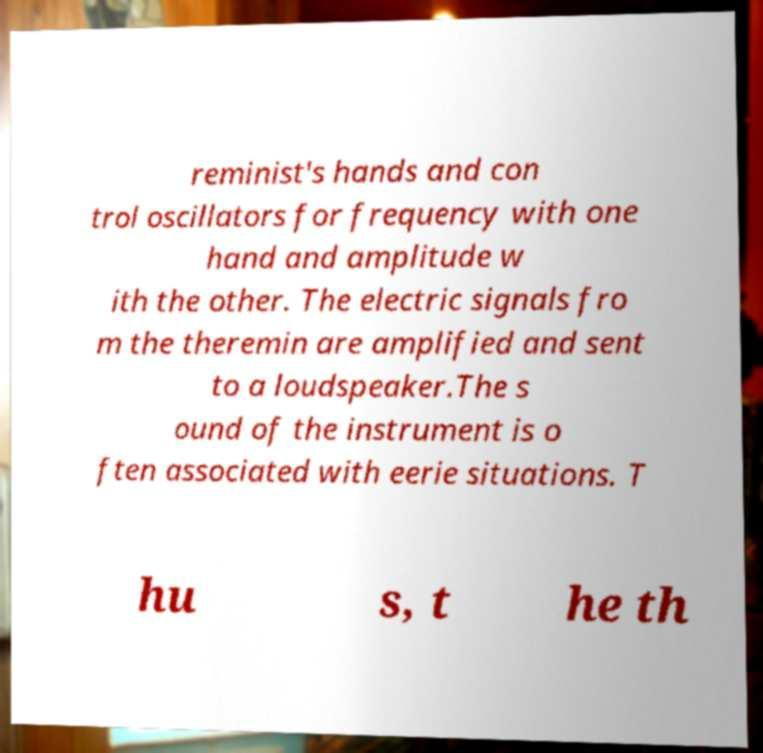There's text embedded in this image that I need extracted. Can you transcribe it verbatim? reminist's hands and con trol oscillators for frequency with one hand and amplitude w ith the other. The electric signals fro m the theremin are amplified and sent to a loudspeaker.The s ound of the instrument is o ften associated with eerie situations. T hu s, t he th 